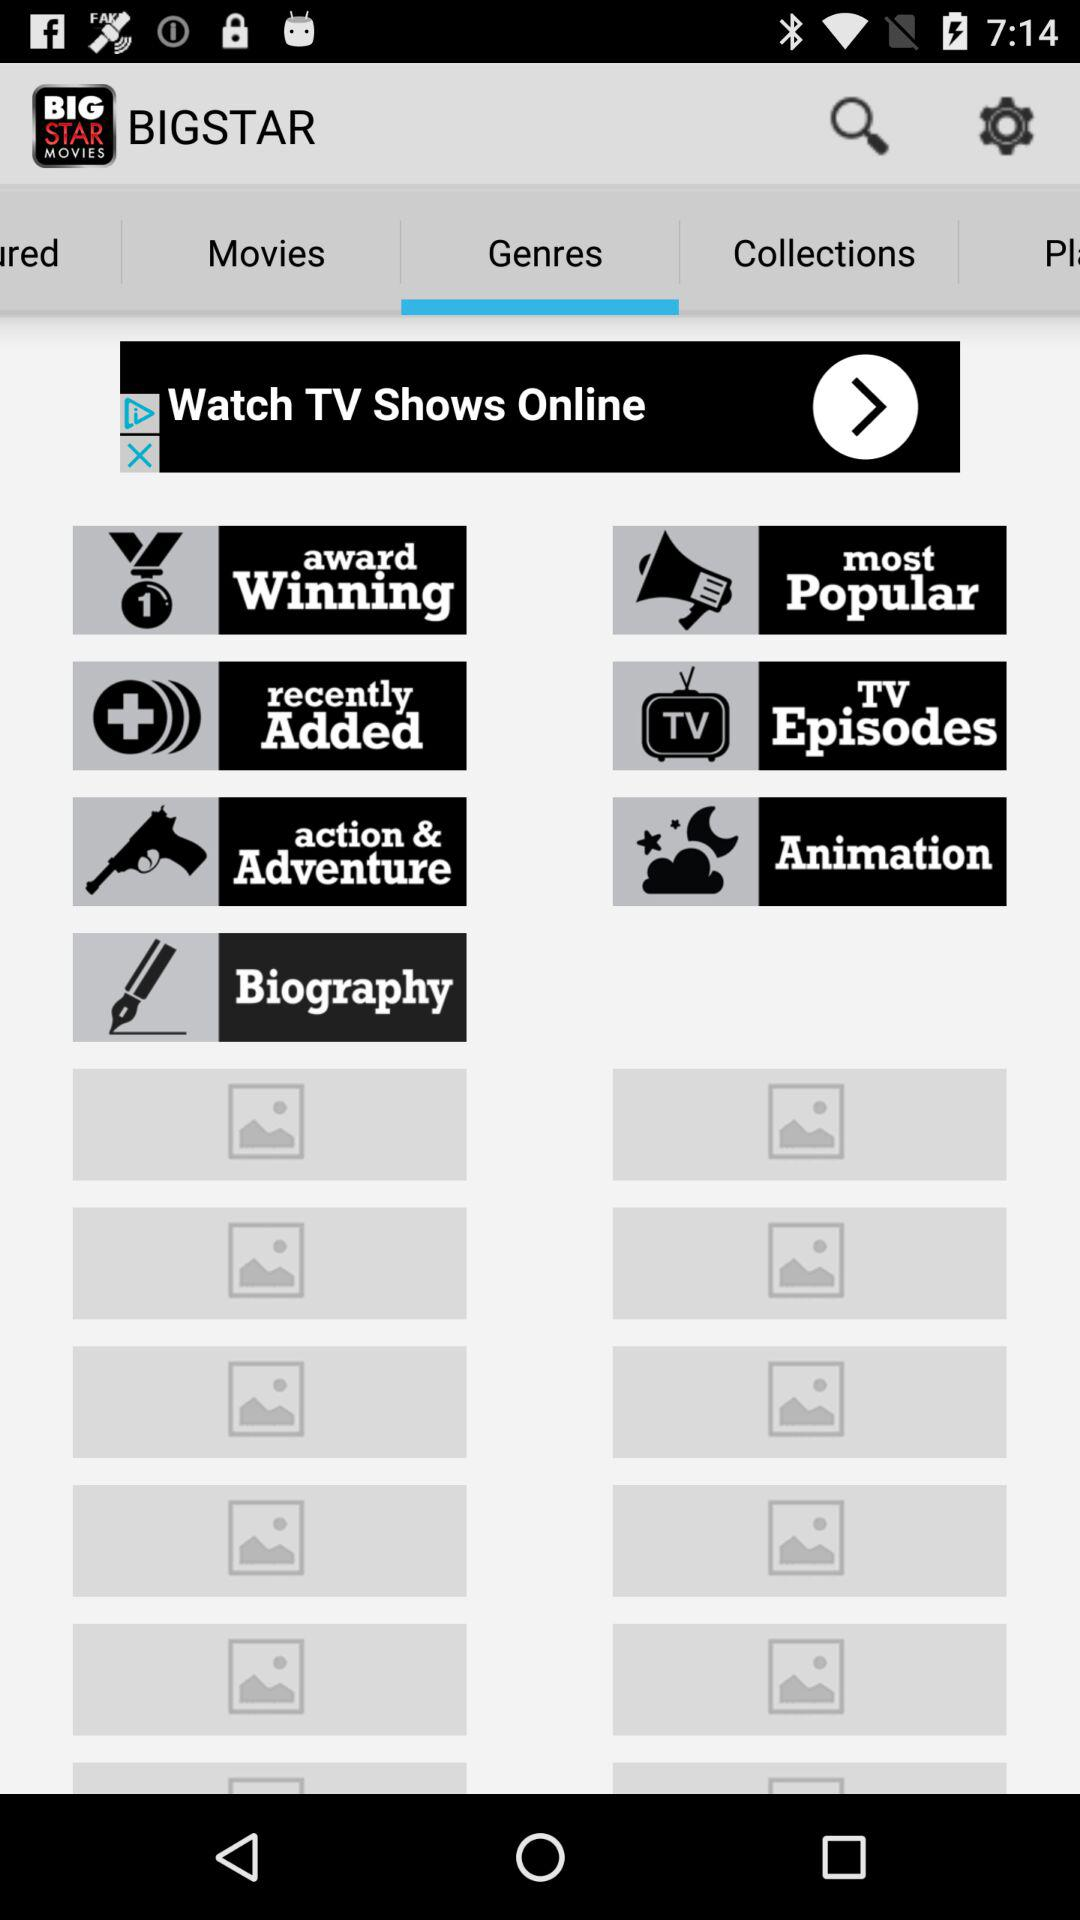What is the application name? The application name is "BIGSTAR". 